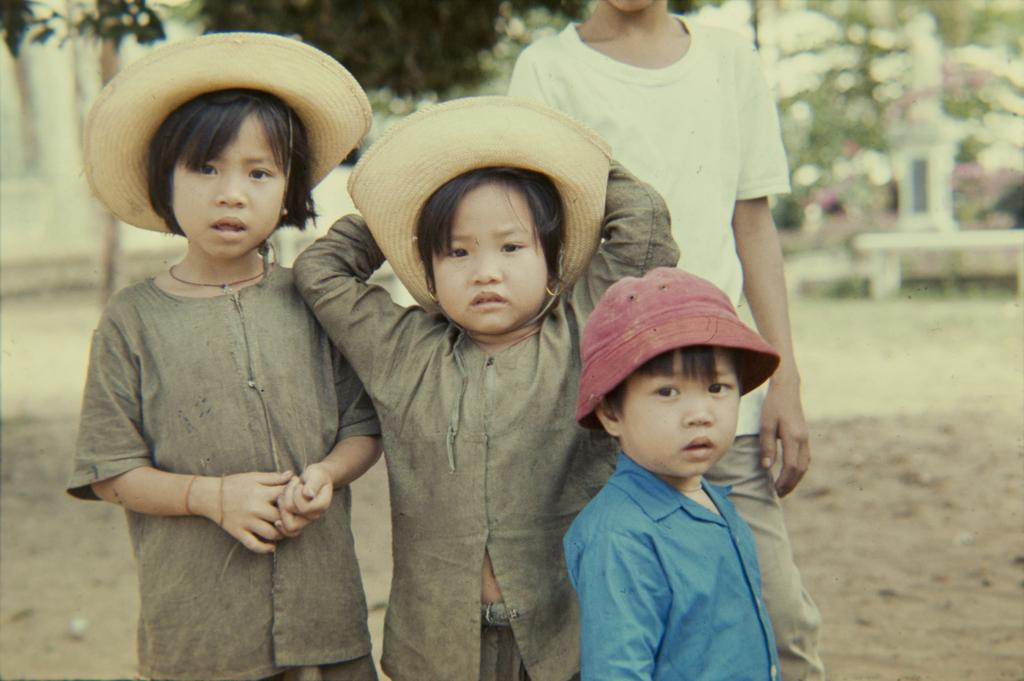How many children are present in the image? There are three children in the image. What are the children wearing on their heads? Two of the children are wearing hats, and one child is wearing a cap. What can be seen in the background of the image? There are green color trees in the background. What type of advice is the oven giving to the children in the image? There is no oven present in the image, so it cannot give any advice to the children. 